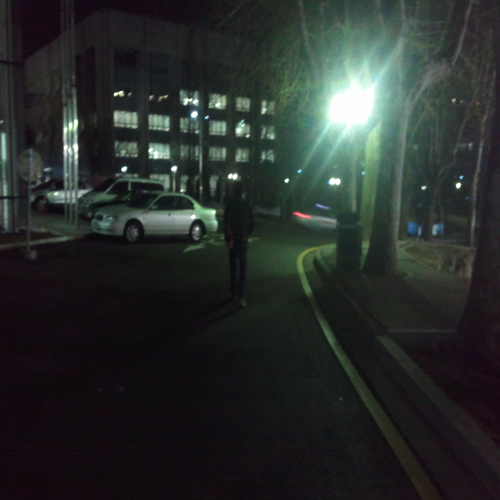Can you describe the atmosphere or mood of the scene in this image? The photo captures a nighttime setting, likely in an urban area. A solitary figure stands in the foreground, possibly a pedestrian, adding a sense of solitude or quiet to the image. The street lights cast a soft glow, creating a contrast with the shadows and giving the scene a slightly mysterious ambiance. 